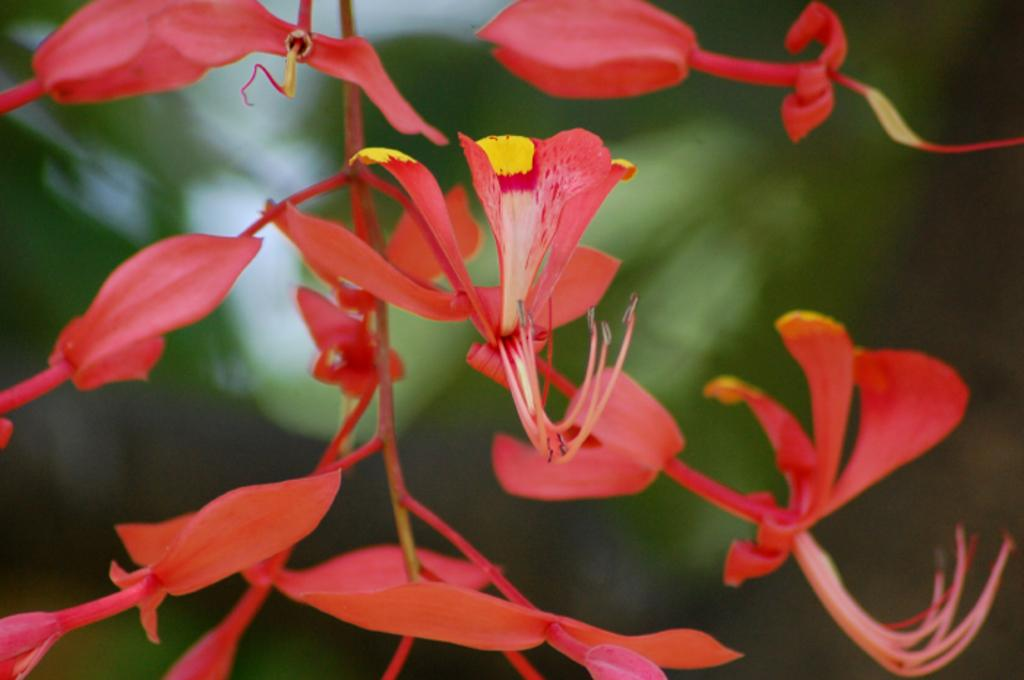What type of plant is visible in the image? There is a plant with flowers in the image. How is the background of the image depicted? The background of the image is blurred. Can you describe any objects visible in the background? Unfortunately, the provided facts do not give any specific details about the objects in the background. How many ants can be seen crawling on the growth in the image? There is no growth or ants present in the image. 